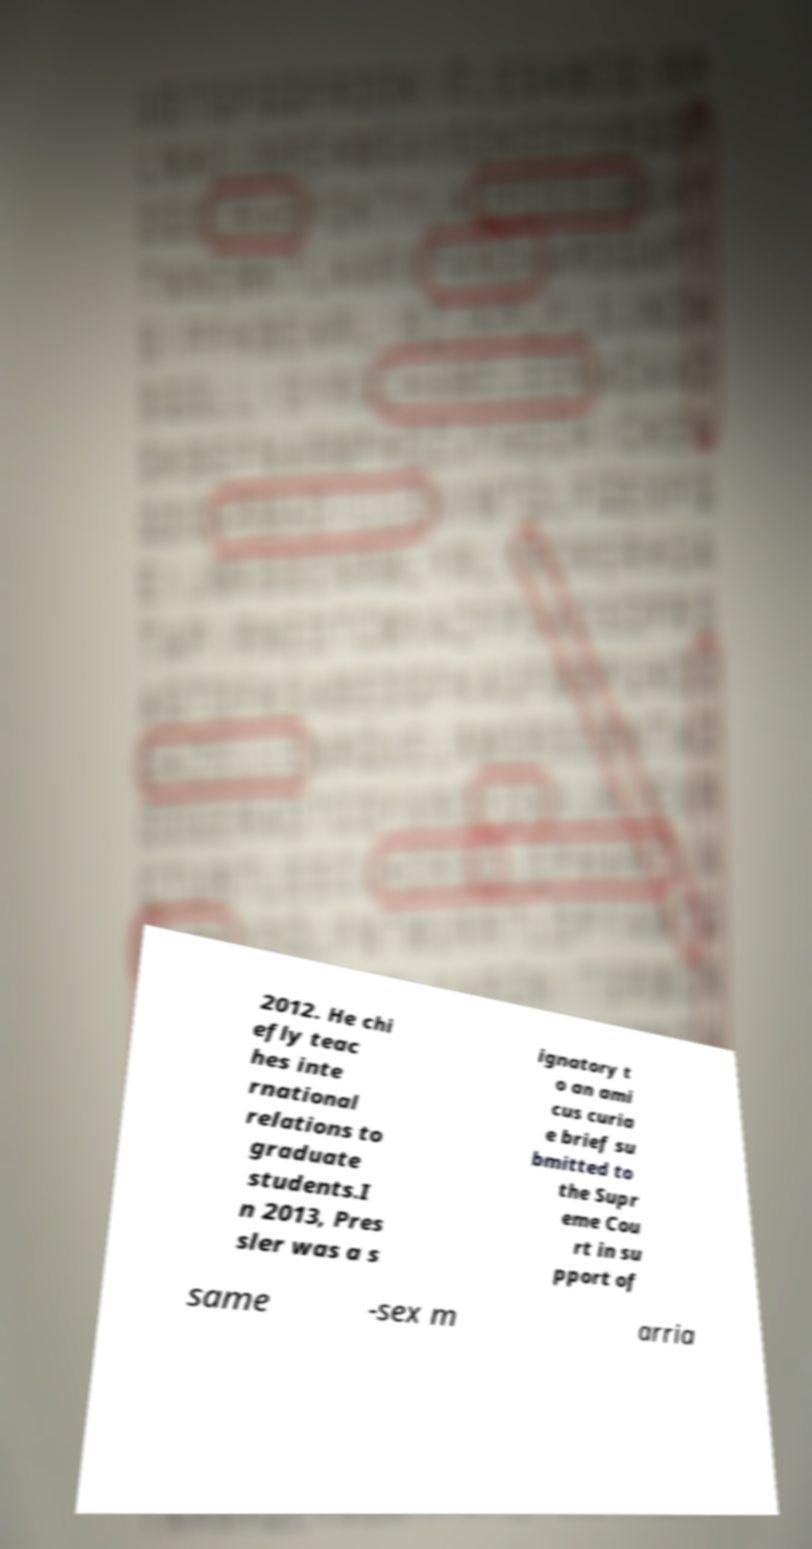Can you accurately transcribe the text from the provided image for me? 2012. He chi efly teac hes inte rnational relations to graduate students.I n 2013, Pres sler was a s ignatory t o an ami cus curia e brief su bmitted to the Supr eme Cou rt in su pport of same -sex m arria 